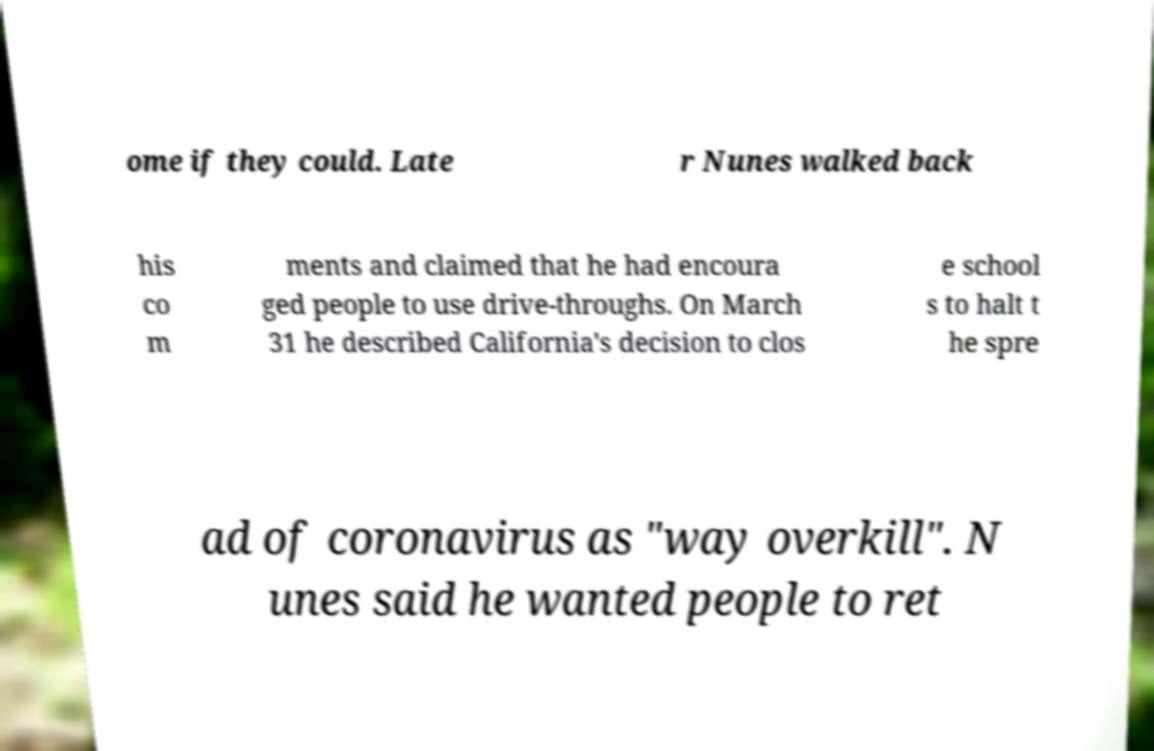Could you extract and type out the text from this image? ome if they could. Late r Nunes walked back his co m ments and claimed that he had encoura ged people to use drive-throughs. On March 31 he described California's decision to clos e school s to halt t he spre ad of coronavirus as "way overkill". N unes said he wanted people to ret 